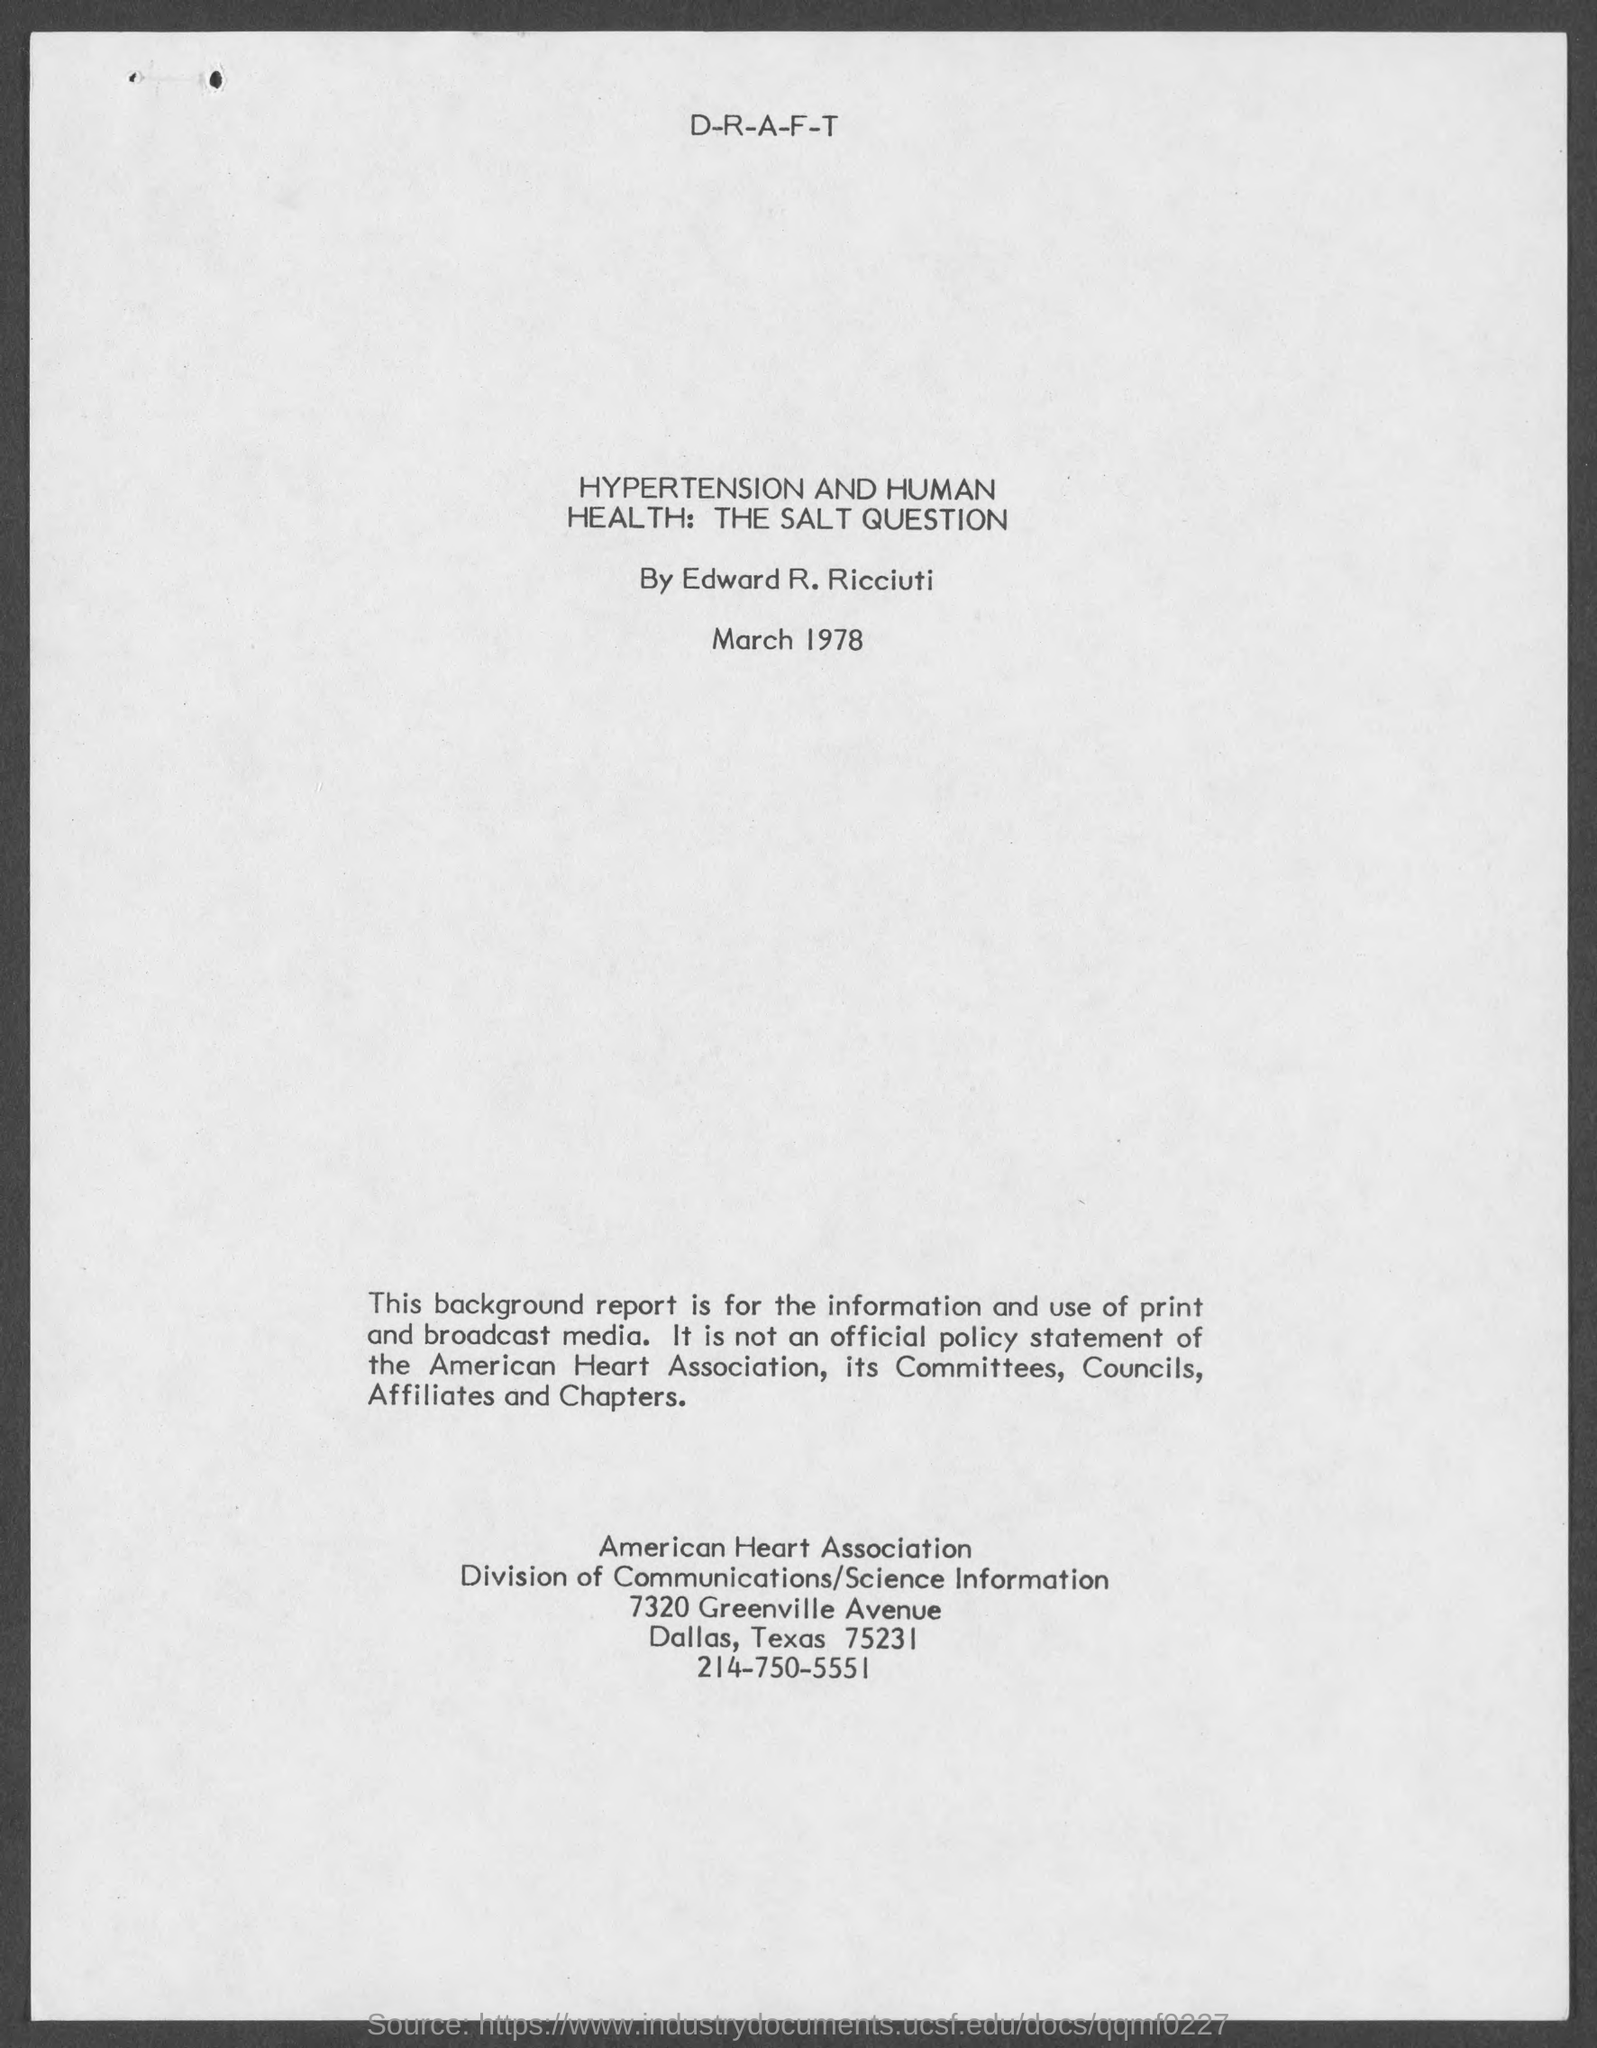Indicate a few pertinent items in this graphic. Edward R. Ricciuti, who worked on Hypertension and Human Health, The Salt Question, is a notable individual. 